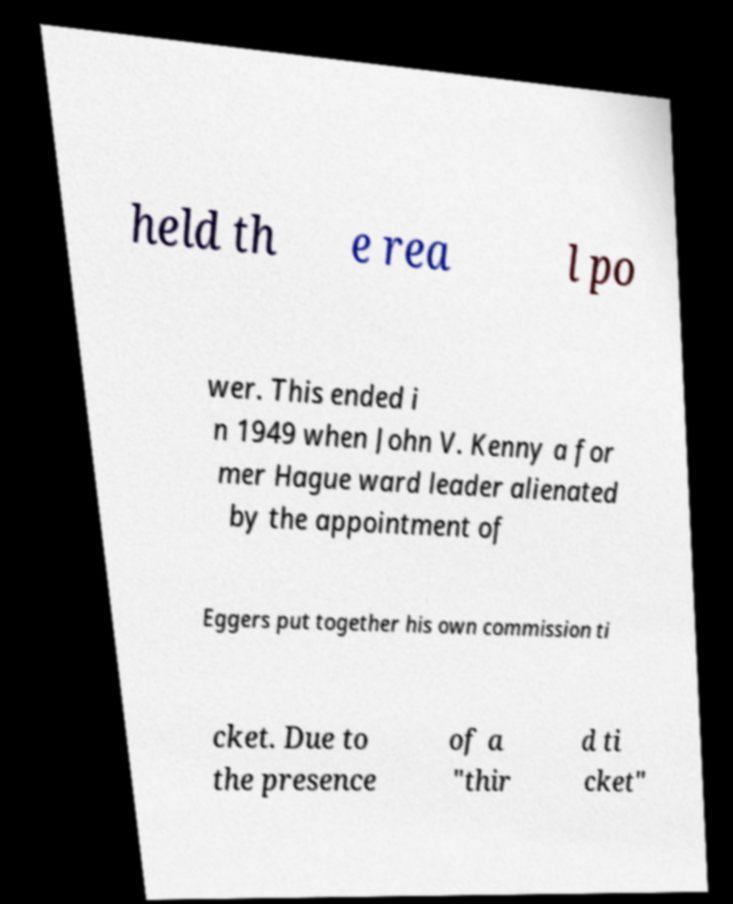Can you accurately transcribe the text from the provided image for me? held th e rea l po wer. This ended i n 1949 when John V. Kenny a for mer Hague ward leader alienated by the appointment of Eggers put together his own commission ti cket. Due to the presence of a "thir d ti cket" 